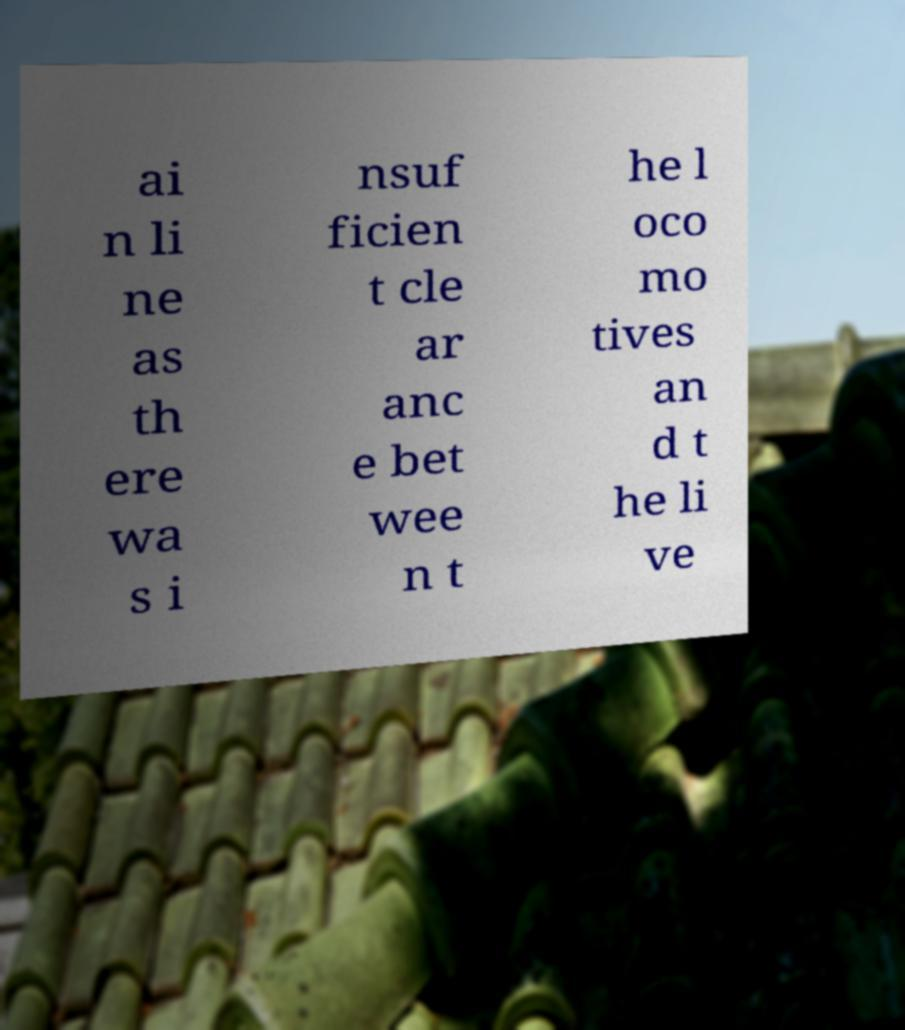Please read and relay the text visible in this image. What does it say? ai n li ne as th ere wa s i nsuf ficien t cle ar anc e bet wee n t he l oco mo tives an d t he li ve 